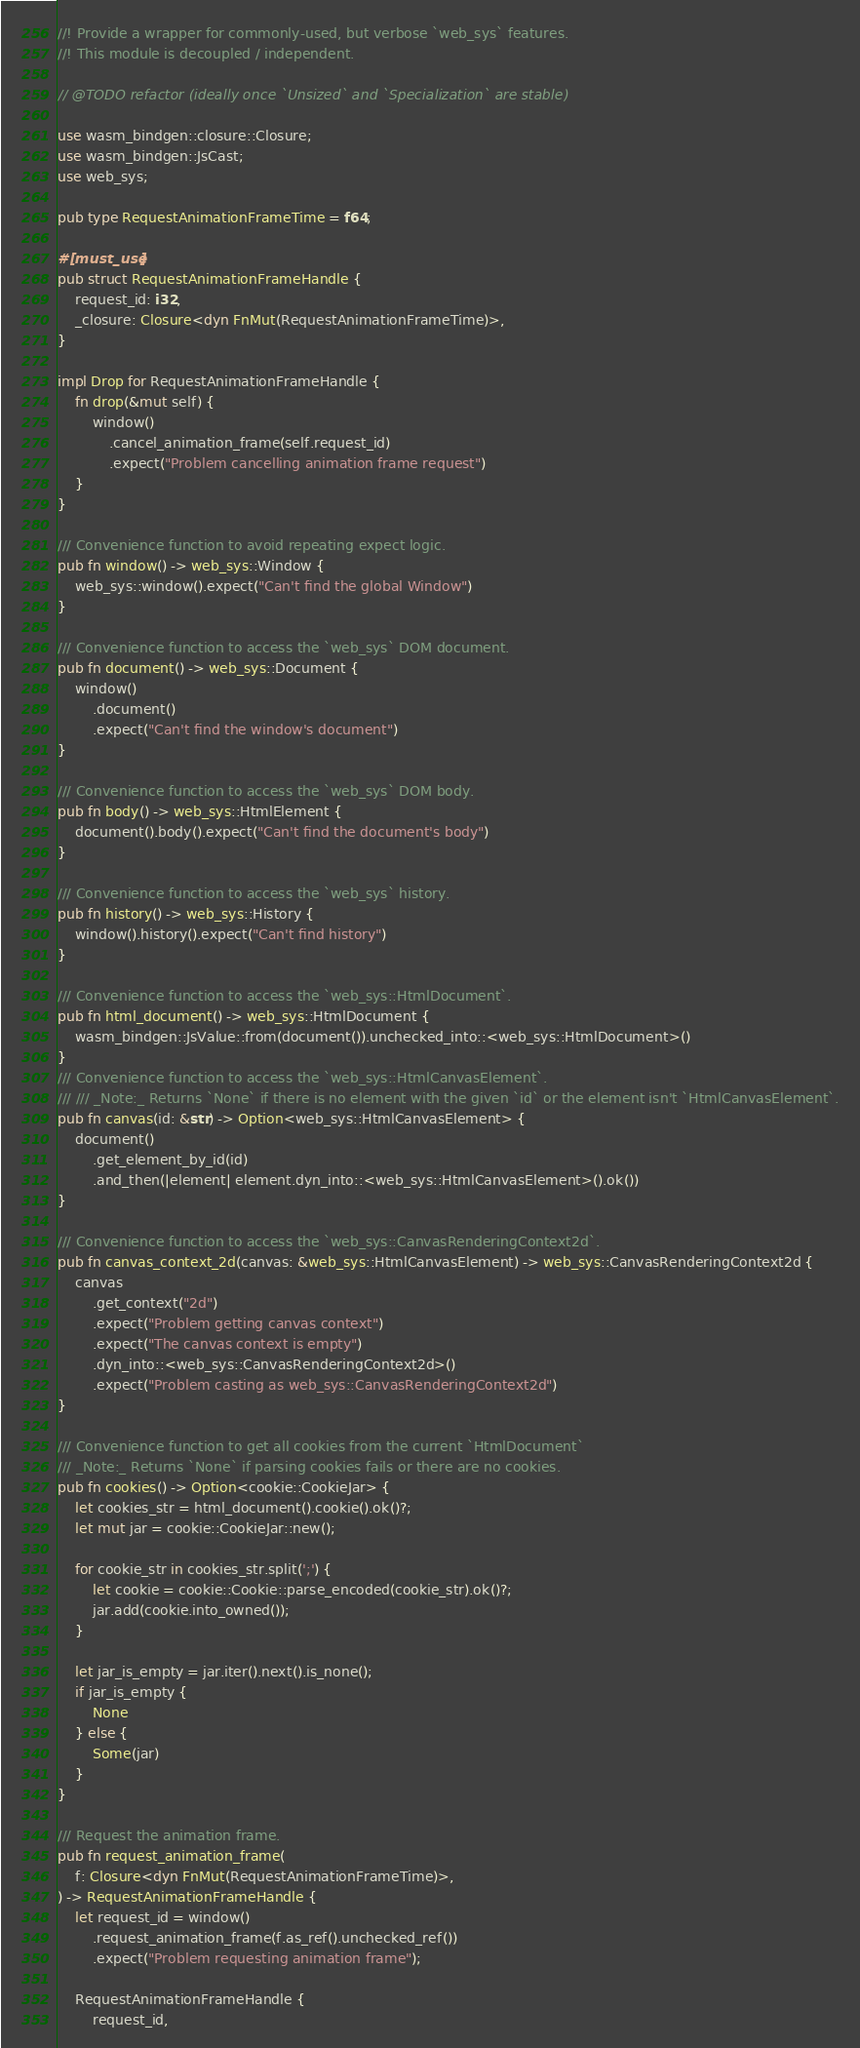Convert code to text. <code><loc_0><loc_0><loc_500><loc_500><_Rust_>//! Provide a wrapper for commonly-used, but verbose `web_sys` features.
//! This module is decoupled / independent.

// @TODO refactor (ideally once `Unsized` and `Specialization` are stable)

use wasm_bindgen::closure::Closure;
use wasm_bindgen::JsCast;
use web_sys;

pub type RequestAnimationFrameTime = f64;

#[must_use]
pub struct RequestAnimationFrameHandle {
    request_id: i32,
    _closure: Closure<dyn FnMut(RequestAnimationFrameTime)>,
}

impl Drop for RequestAnimationFrameHandle {
    fn drop(&mut self) {
        window()
            .cancel_animation_frame(self.request_id)
            .expect("Problem cancelling animation frame request")
    }
}

/// Convenience function to avoid repeating expect logic.
pub fn window() -> web_sys::Window {
    web_sys::window().expect("Can't find the global Window")
}

/// Convenience function to access the `web_sys` DOM document.
pub fn document() -> web_sys::Document {
    window()
        .document()
        .expect("Can't find the window's document")
}

/// Convenience function to access the `web_sys` DOM body.
pub fn body() -> web_sys::HtmlElement {
    document().body().expect("Can't find the document's body")
}

/// Convenience function to access the `web_sys` history.
pub fn history() -> web_sys::History {
    window().history().expect("Can't find history")
}

/// Convenience function to access the `web_sys::HtmlDocument`.
pub fn html_document() -> web_sys::HtmlDocument {
    wasm_bindgen::JsValue::from(document()).unchecked_into::<web_sys::HtmlDocument>()
}
/// Convenience function to access the `web_sys::HtmlCanvasElement`.
/// /// _Note:_ Returns `None` if there is no element with the given `id` or the element isn't `HtmlCanvasElement`.
pub fn canvas(id: &str) -> Option<web_sys::HtmlCanvasElement> {
    document()
        .get_element_by_id(id)
        .and_then(|element| element.dyn_into::<web_sys::HtmlCanvasElement>().ok())
}

/// Convenience function to access the `web_sys::CanvasRenderingContext2d`.
pub fn canvas_context_2d(canvas: &web_sys::HtmlCanvasElement) -> web_sys::CanvasRenderingContext2d {
    canvas
        .get_context("2d")
        .expect("Problem getting canvas context")
        .expect("The canvas context is empty")
        .dyn_into::<web_sys::CanvasRenderingContext2d>()
        .expect("Problem casting as web_sys::CanvasRenderingContext2d")
}

/// Convenience function to get all cookies from the current `HtmlDocument`
/// _Note:_ Returns `None` if parsing cookies fails or there are no cookies.
pub fn cookies() -> Option<cookie::CookieJar> {
    let cookies_str = html_document().cookie().ok()?;
    let mut jar = cookie::CookieJar::new();

    for cookie_str in cookies_str.split(';') {
        let cookie = cookie::Cookie::parse_encoded(cookie_str).ok()?;
        jar.add(cookie.into_owned());
    }

    let jar_is_empty = jar.iter().next().is_none();
    if jar_is_empty {
        None
    } else {
        Some(jar)
    }
}

/// Request the animation frame.
pub fn request_animation_frame(
    f: Closure<dyn FnMut(RequestAnimationFrameTime)>,
) -> RequestAnimationFrameHandle {
    let request_id = window()
        .request_animation_frame(f.as_ref().unchecked_ref())
        .expect("Problem requesting animation frame");

    RequestAnimationFrameHandle {
        request_id,</code> 